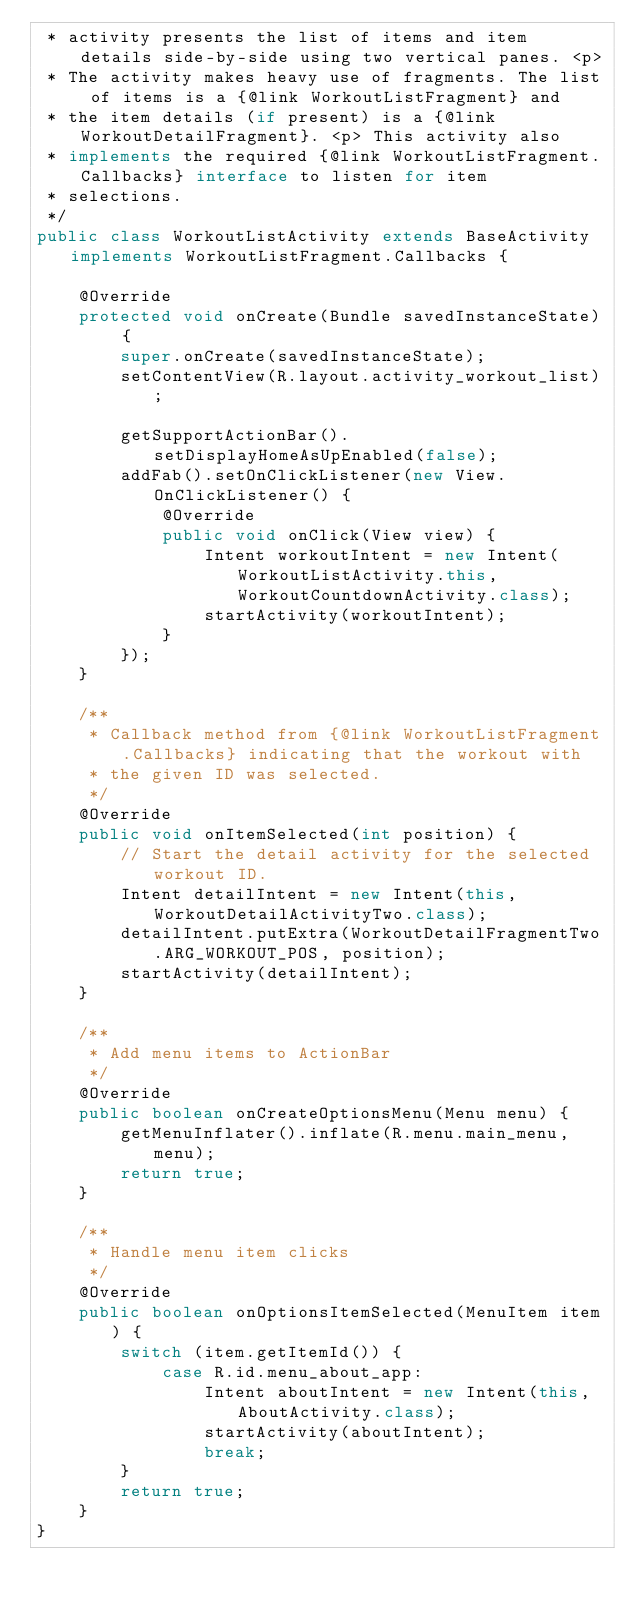<code> <loc_0><loc_0><loc_500><loc_500><_Java_> * activity presents the list of items and item details side-by-side using two vertical panes. <p>
 * The activity makes heavy use of fragments. The list of items is a {@link WorkoutListFragment} and
 * the item details (if present) is a {@link WorkoutDetailFragment}. <p> This activity also
 * implements the required {@link WorkoutListFragment.Callbacks} interface to listen for item
 * selections.
 */
public class WorkoutListActivity extends BaseActivity implements WorkoutListFragment.Callbacks {

    @Override
    protected void onCreate(Bundle savedInstanceState) {
        super.onCreate(savedInstanceState);
        setContentView(R.layout.activity_workout_list);

        getSupportActionBar().setDisplayHomeAsUpEnabled(false);
        addFab().setOnClickListener(new View.OnClickListener() {
            @Override
            public void onClick(View view) {
                Intent workoutIntent = new Intent(WorkoutListActivity.this, WorkoutCountdownActivity.class);
                startActivity(workoutIntent);
            }
        });
    }

    /**
     * Callback method from {@link WorkoutListFragment.Callbacks} indicating that the workout with
     * the given ID was selected.
     */
    @Override
    public void onItemSelected(int position) {
        // Start the detail activity for the selected workout ID.
        Intent detailIntent = new Intent(this, WorkoutDetailActivityTwo.class);
        detailIntent.putExtra(WorkoutDetailFragmentTwo.ARG_WORKOUT_POS, position);
        startActivity(detailIntent);
    }

    /**
     * Add menu items to ActionBar
     */
    @Override
    public boolean onCreateOptionsMenu(Menu menu) {
        getMenuInflater().inflate(R.menu.main_menu, menu);
        return true;
    }

    /**
     * Handle menu item clicks
     */
    @Override
    public boolean onOptionsItemSelected(MenuItem item) {
        switch (item.getItemId()) {
            case R.id.menu_about_app:
                Intent aboutIntent = new Intent(this, AboutActivity.class);
                startActivity(aboutIntent);
                break;
        }
        return true;
    }
}
</code> 